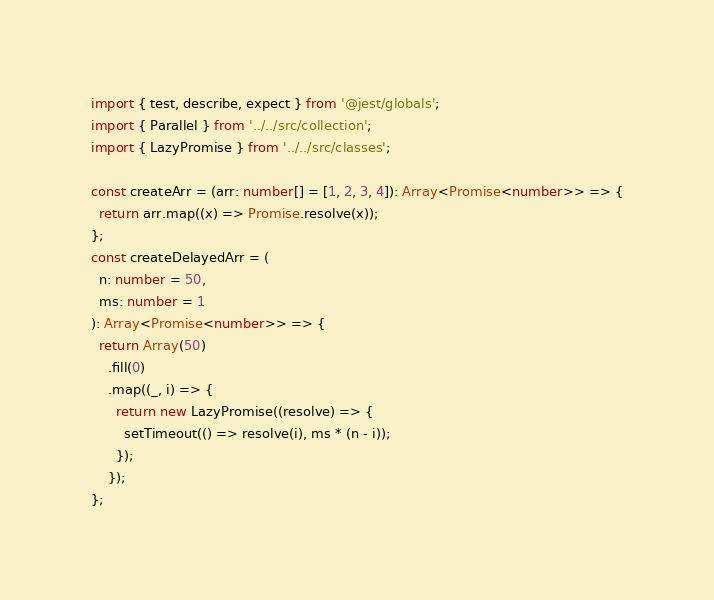Convert code to text. <code><loc_0><loc_0><loc_500><loc_500><_TypeScript_>import { test, describe, expect } from '@jest/globals';
import { Parallel } from '../../src/collection';
import { LazyPromise } from '../../src/classes';

const createArr = (arr: number[] = [1, 2, 3, 4]): Array<Promise<number>> => {
  return arr.map((x) => Promise.resolve(x));
};
const createDelayedArr = (
  n: number = 50,
  ms: number = 1
): Array<Promise<number>> => {
  return Array(50)
    .fill(0)
    .map((_, i) => {
      return new LazyPromise((resolve) => {
        setTimeout(() => resolve(i), ms * (n - i));
      });
    });
};
</code> 